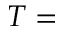<formula> <loc_0><loc_0><loc_500><loc_500>T =</formula> 